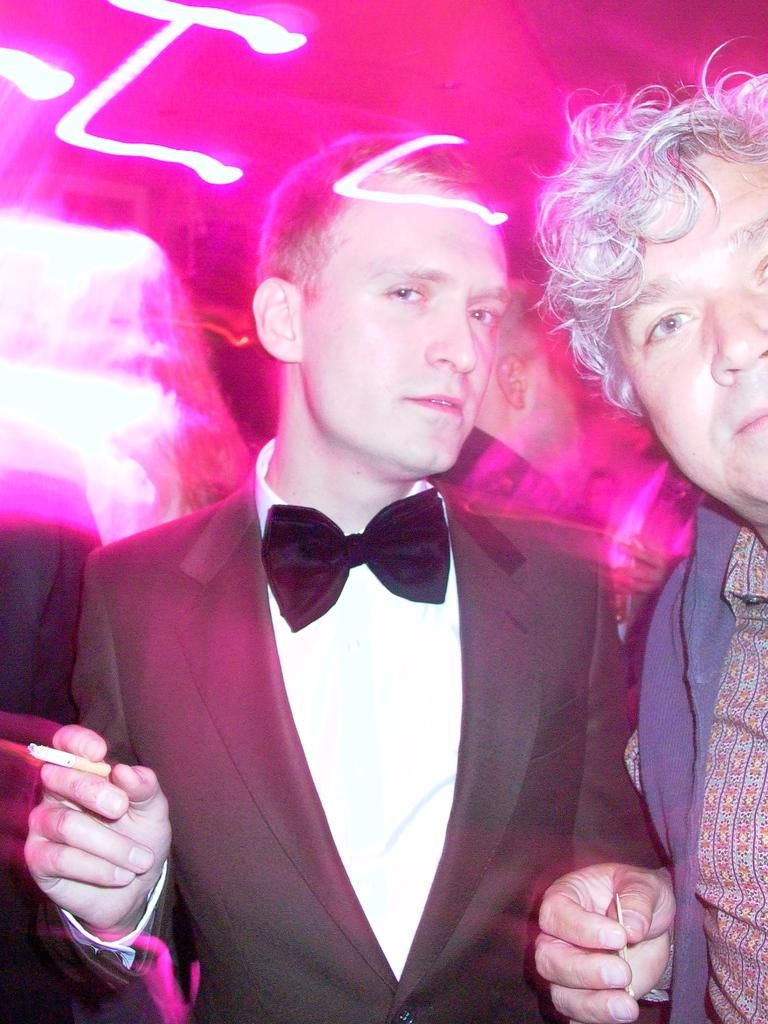How many people are in the image? There are two persons in the image. What are the people in the image doing? Both persons are looking at the camera. Can you describe any objects or items held by the persons? One of the persons is holding a cigarette in his hand. What type of spring can be seen in the image? There is no spring present in the image. How does the cigarette cause the person to stamp their feet in the image? The cigarette does not cause the person to stamp their feet in the image; it is simply being held in the person's hand. 